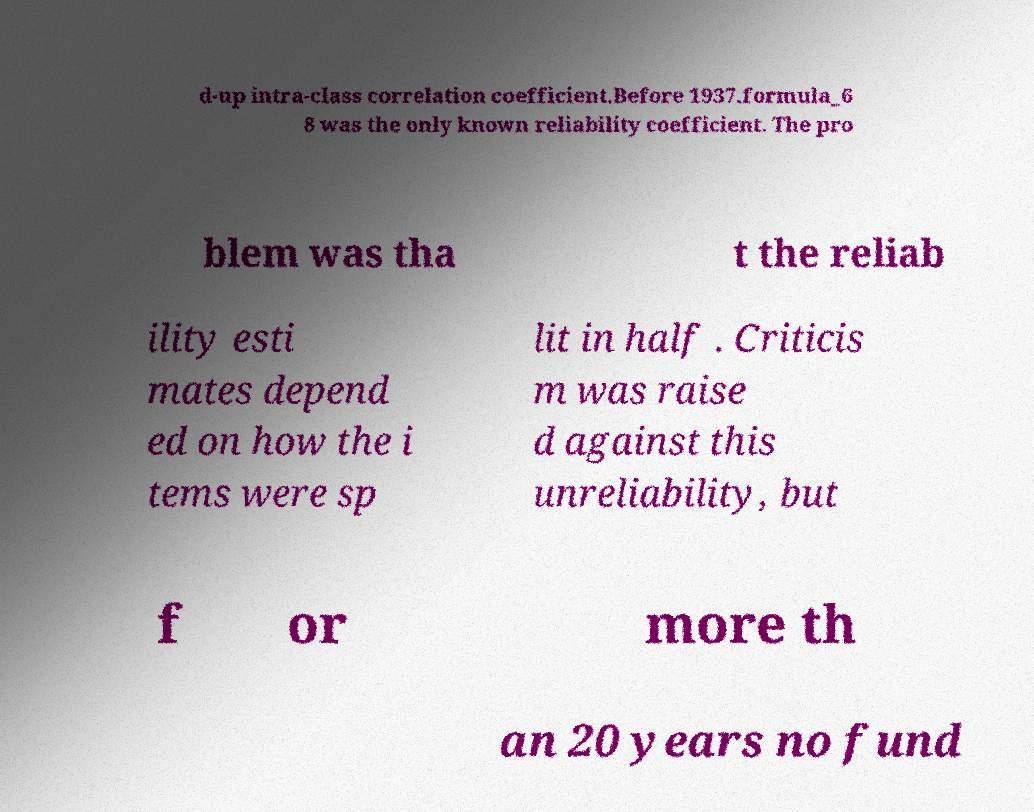Please read and relay the text visible in this image. What does it say? d-up intra-class correlation coefficient.Before 1937.formula_6 8 was the only known reliability coefficient. The pro blem was tha t the reliab ility esti mates depend ed on how the i tems were sp lit in half . Criticis m was raise d against this unreliability, but f or more th an 20 years no fund 